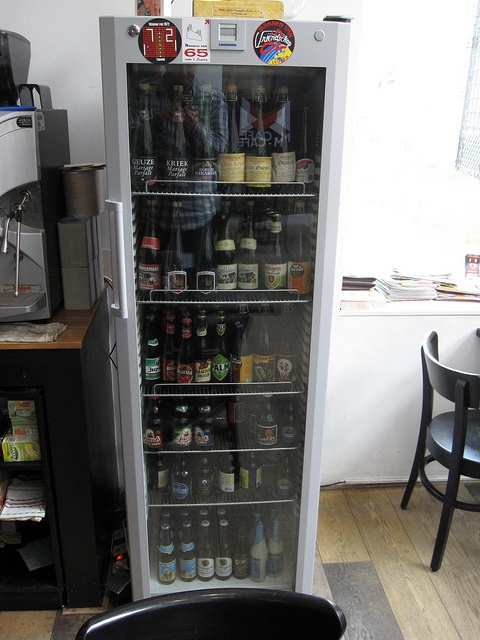Describe the objects in this image and their specific colors. I can see refrigerator in lightgray, black, gray, and darkgray tones, bottle in lightgray, black, gray, and maroon tones, chair in lightgray, black, gray, and white tones, chair in lightgray, black, gray, darkgray, and white tones, and bottle in lightgray, black, gray, and purple tones in this image. 